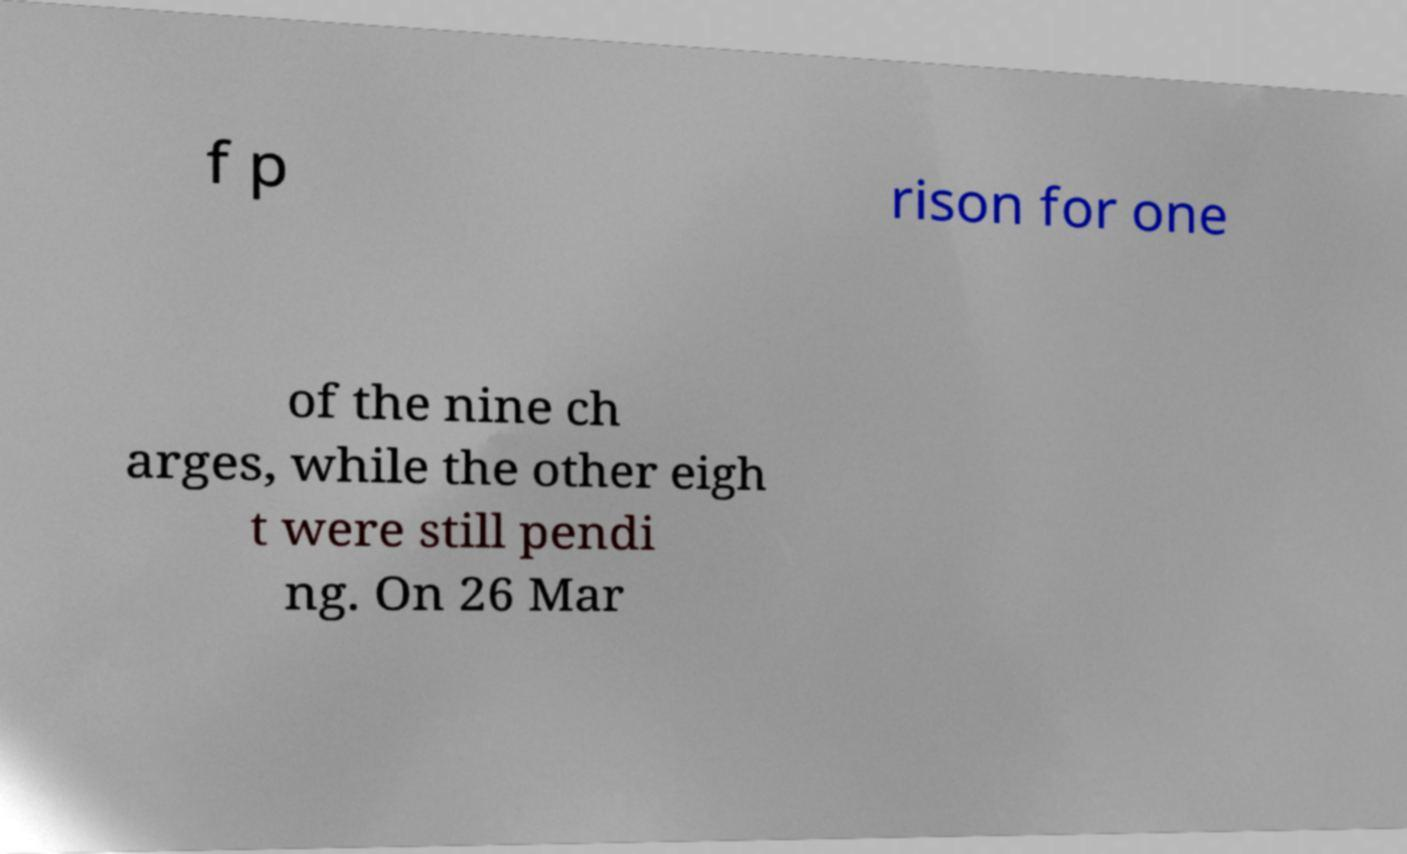What messages or text are displayed in this image? I need them in a readable, typed format. f p rison for one of the nine ch arges, while the other eigh t were still pendi ng. On 26 Mar 